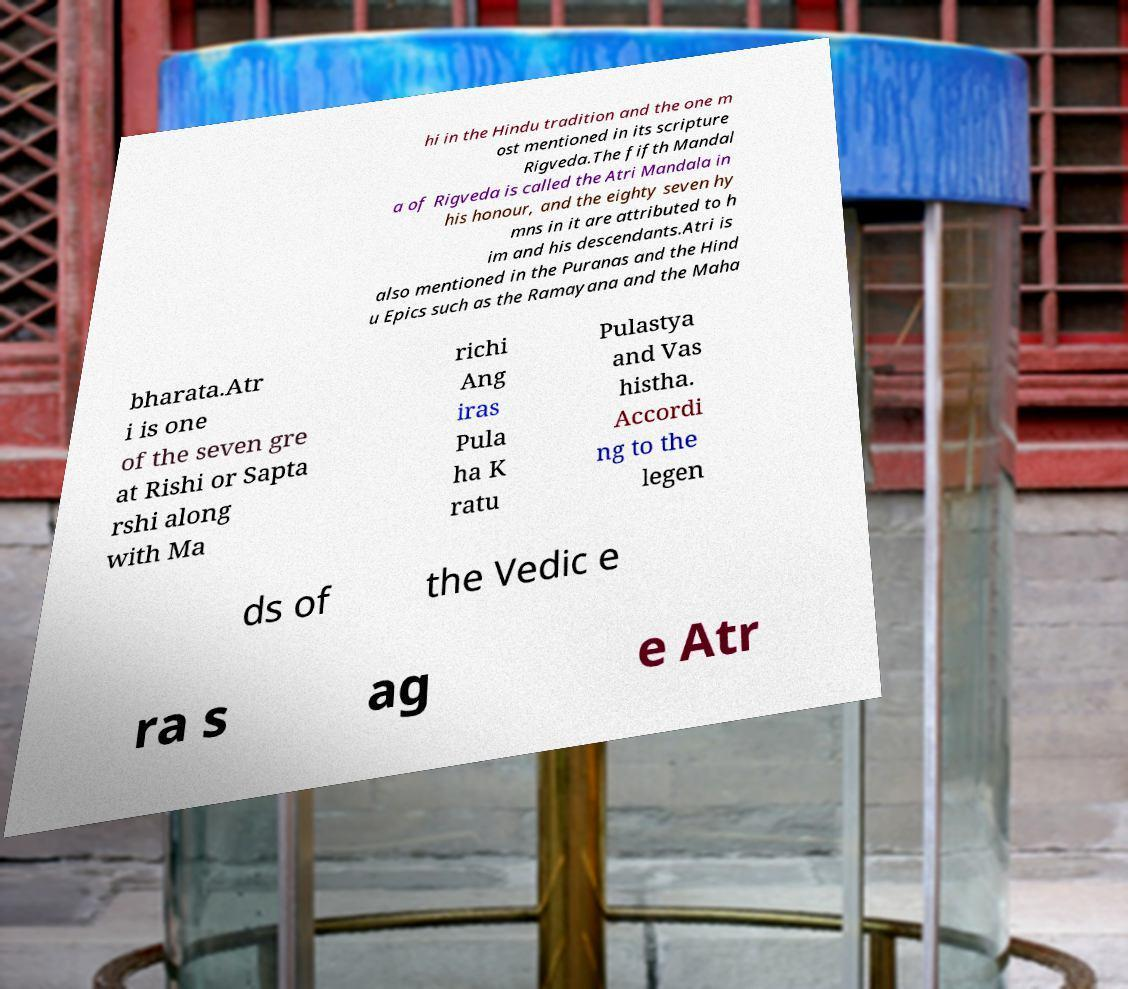Please identify and transcribe the text found in this image. hi in the Hindu tradition and the one m ost mentioned in its scripture Rigveda.The fifth Mandal a of Rigveda is called the Atri Mandala in his honour, and the eighty seven hy mns in it are attributed to h im and his descendants.Atri is also mentioned in the Puranas and the Hind u Epics such as the Ramayana and the Maha bharata.Atr i is one of the seven gre at Rishi or Sapta rshi along with Ma richi Ang iras Pula ha K ratu Pulastya and Vas histha. Accordi ng to the legen ds of the Vedic e ra s ag e Atr 